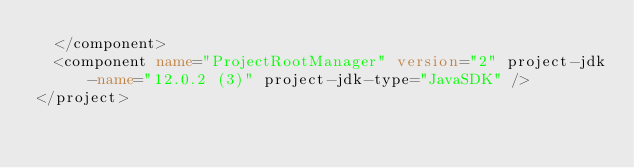Convert code to text. <code><loc_0><loc_0><loc_500><loc_500><_XML_>  </component>
  <component name="ProjectRootManager" version="2" project-jdk-name="12.0.2 (3)" project-jdk-type="JavaSDK" />
</project></code> 